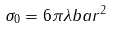<formula> <loc_0><loc_0><loc_500><loc_500>\sigma _ { 0 } = 6 \pi \lambda b a r ^ { 2 }</formula> 